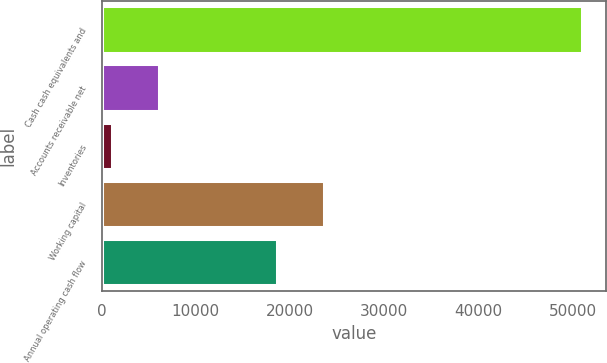Convert chart. <chart><loc_0><loc_0><loc_500><loc_500><bar_chart><fcel>Cash cash equivalents and<fcel>Accounts receivable net<fcel>Inventories<fcel>Working capital<fcel>Annual operating cash flow<nl><fcel>51011<fcel>6047<fcel>1051<fcel>23591<fcel>18595<nl></chart> 